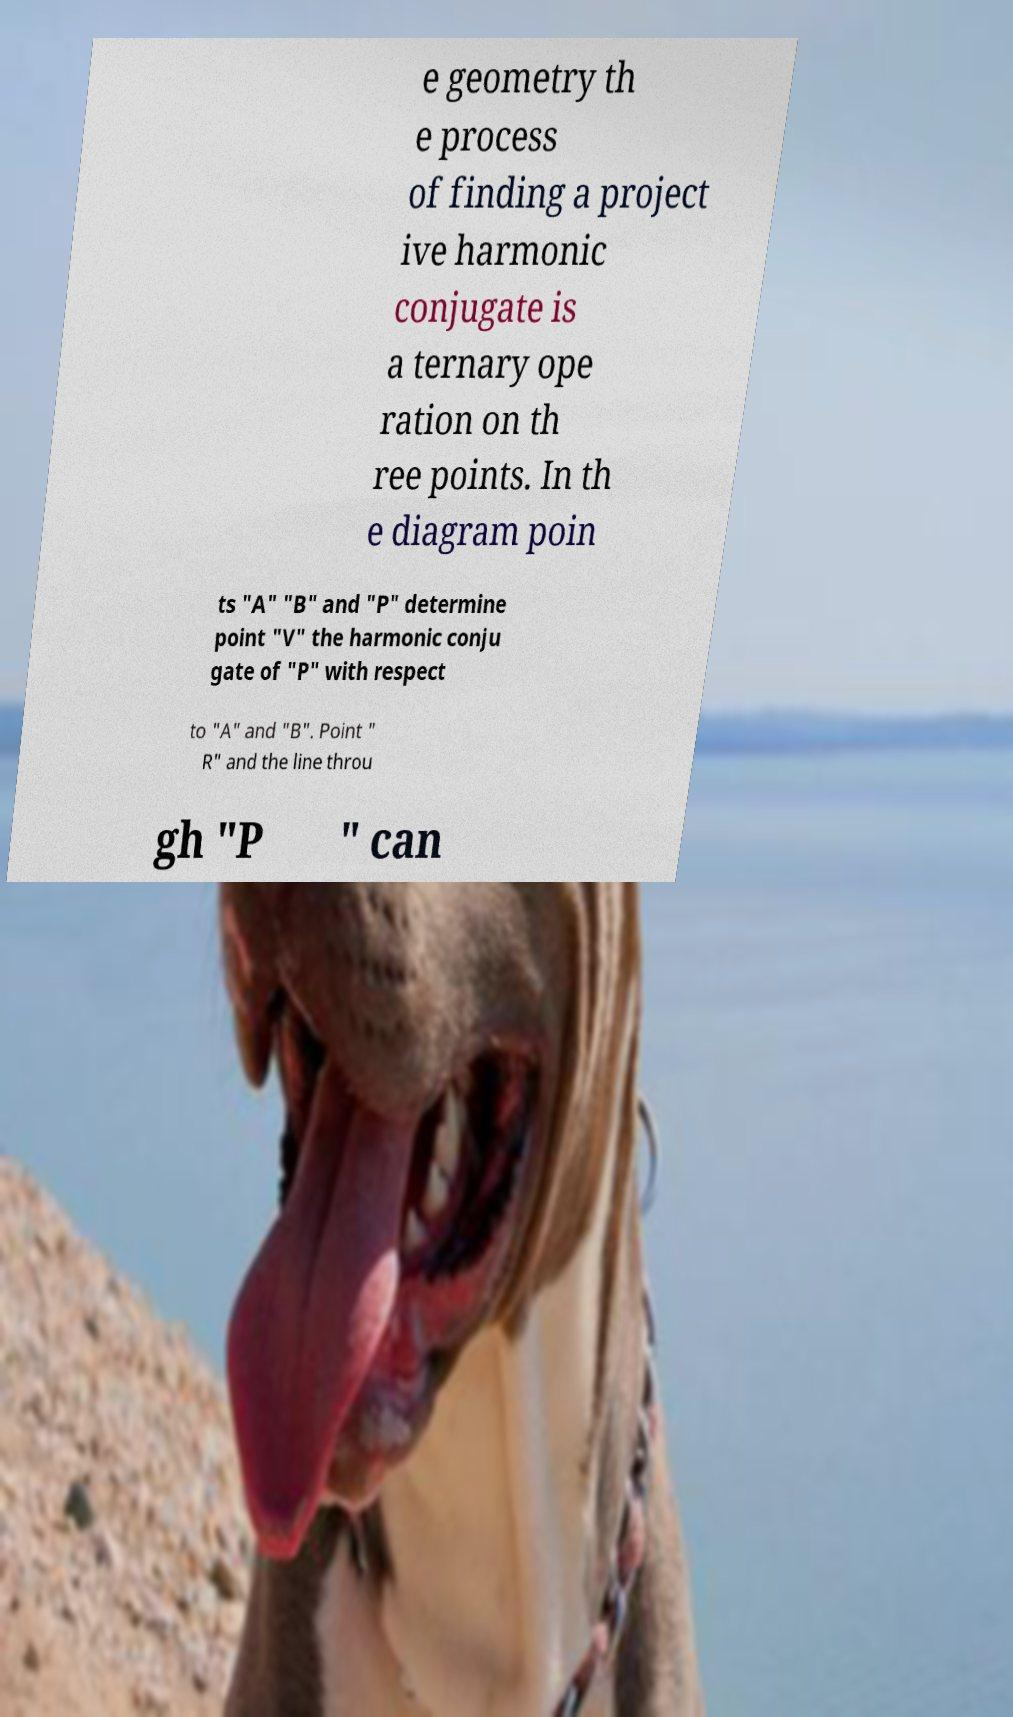I need the written content from this picture converted into text. Can you do that? e geometry th e process of finding a project ive harmonic conjugate is a ternary ope ration on th ree points. In th e diagram poin ts "A" "B" and "P" determine point "V" the harmonic conju gate of "P" with respect to "A" and "B". Point " R" and the line throu gh "P " can 